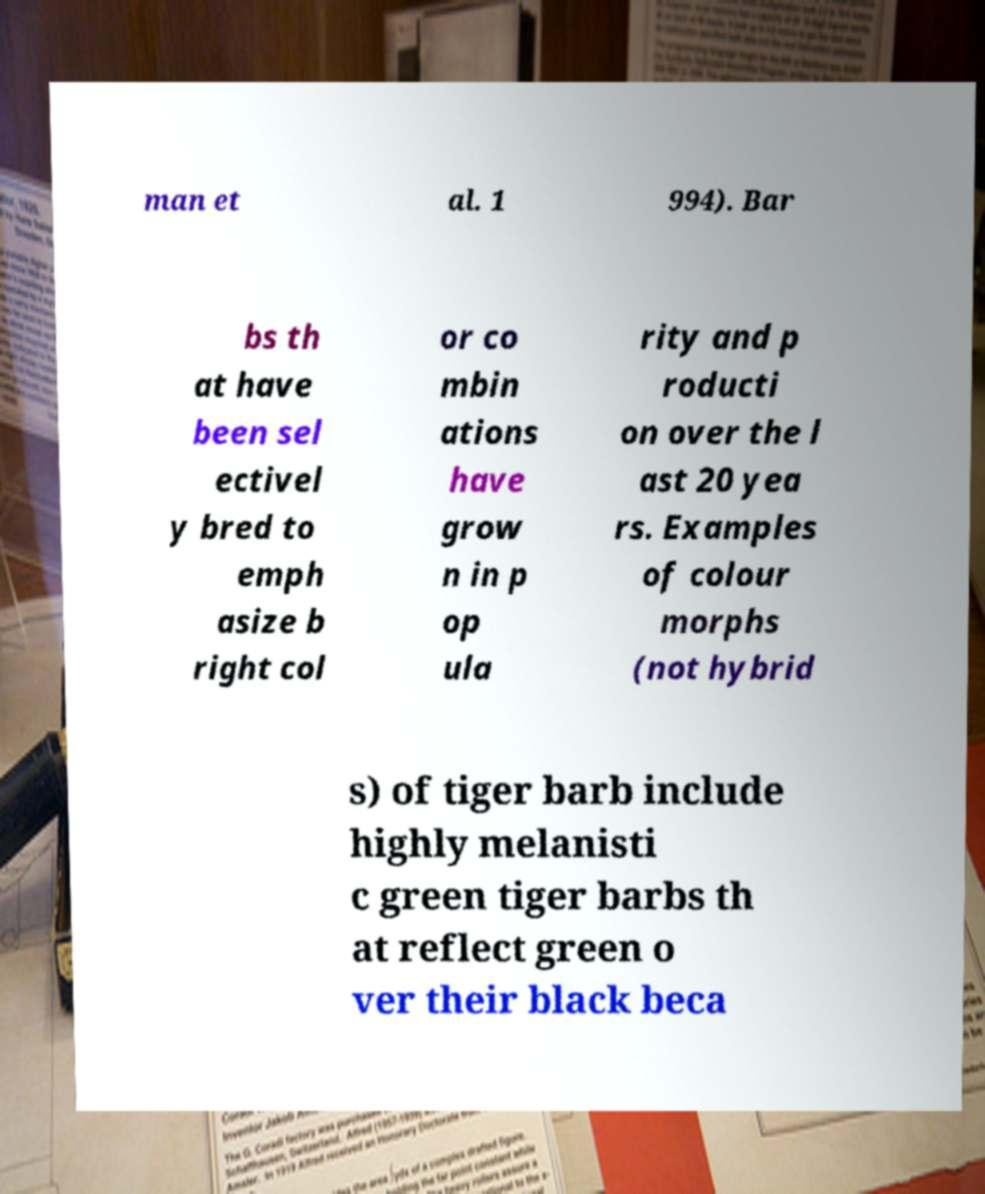What messages or text are displayed in this image? I need them in a readable, typed format. man et al. 1 994). Bar bs th at have been sel ectivel y bred to emph asize b right col or co mbin ations have grow n in p op ula rity and p roducti on over the l ast 20 yea rs. Examples of colour morphs (not hybrid s) of tiger barb include highly melanisti c green tiger barbs th at reflect green o ver their black beca 